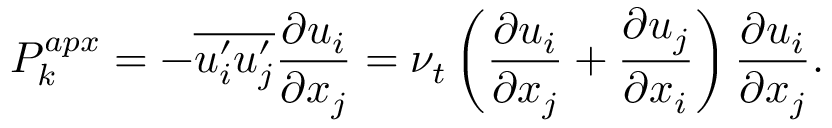Convert formula to latex. <formula><loc_0><loc_0><loc_500><loc_500>P _ { k } ^ { a p x } = - \overline { { u _ { i } ^ { \prime } u _ { j } ^ { \prime } } } \frac { \partial u _ { i } } { \partial x _ { j } } = \nu _ { t } \left ( \frac { \partial u _ { i } } { \partial x _ { j } } + \frac { \partial u _ { j } } { \partial x _ { i } } \right ) \frac { \partial u _ { i } } { \partial x _ { j } } .</formula> 